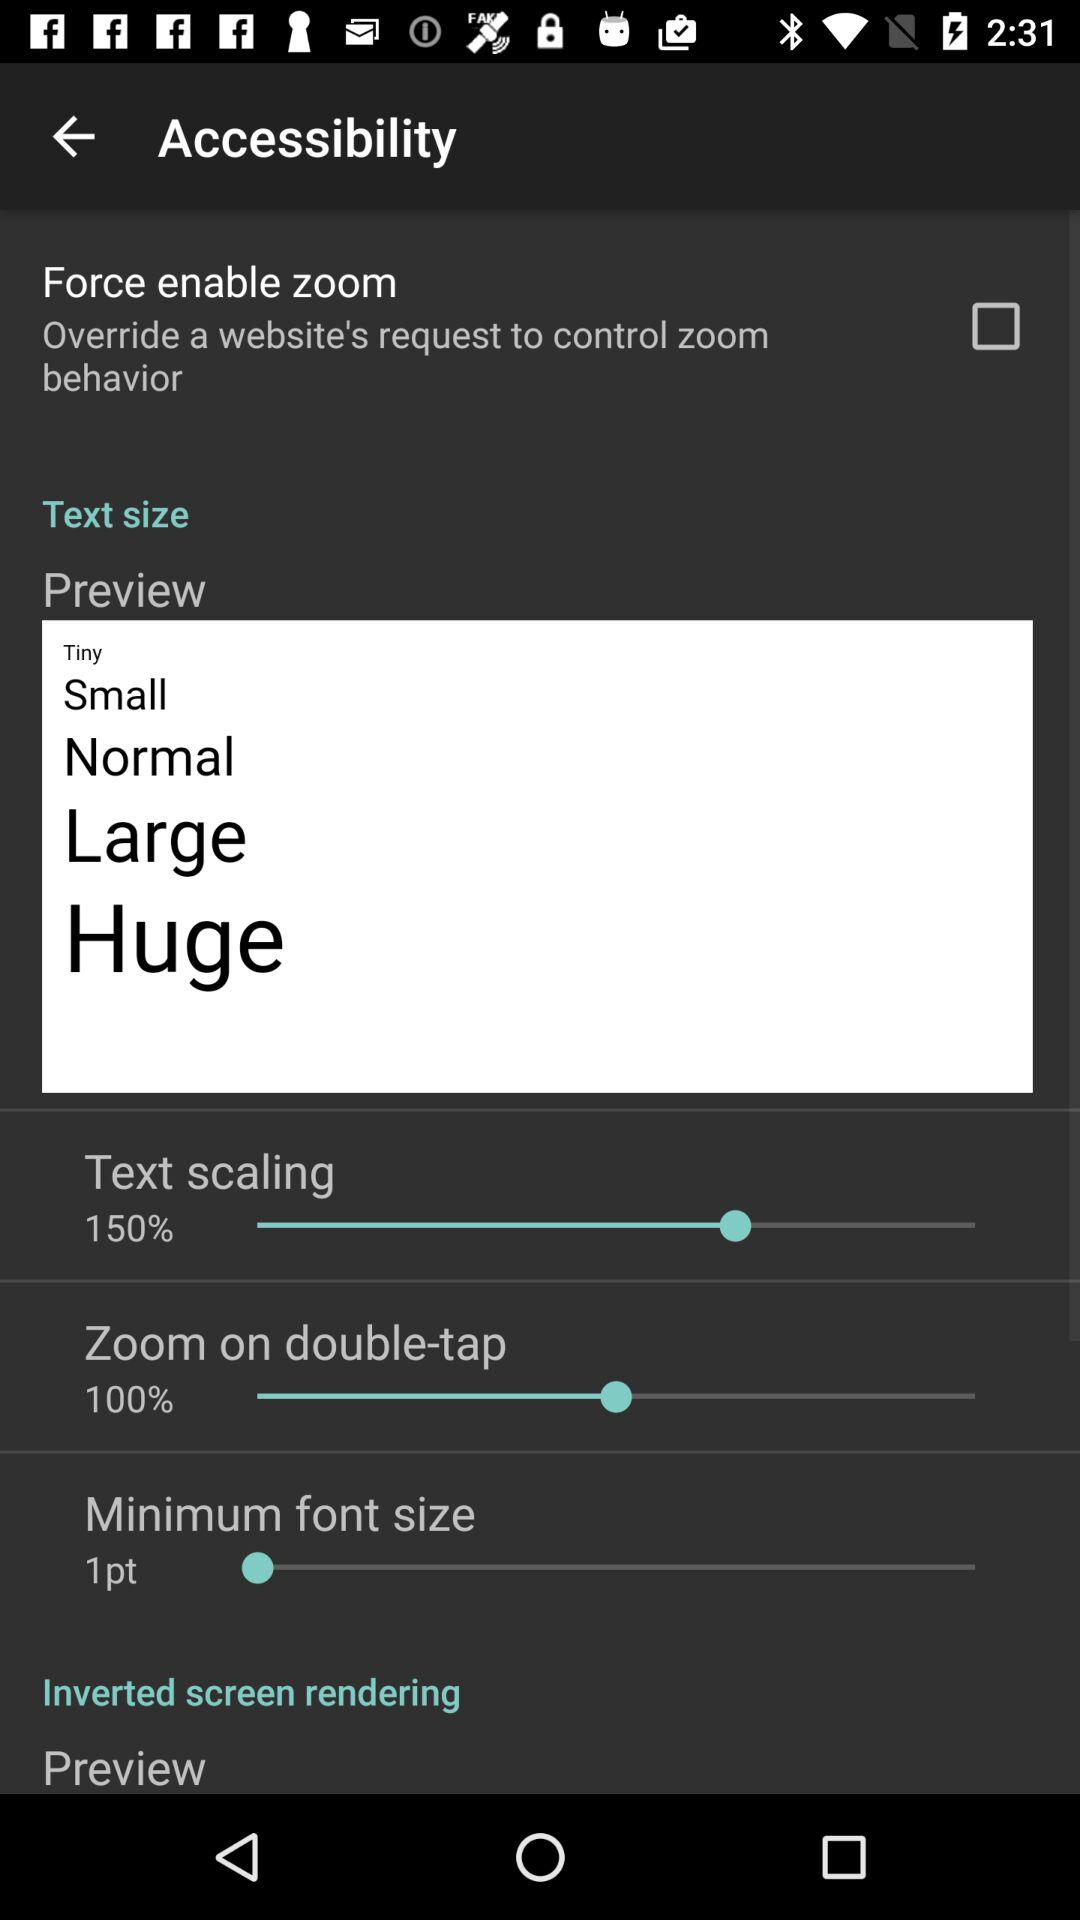What is the status of the "Force enable zoom" setting? The status of the "Force enable zoom" setting is "off". 